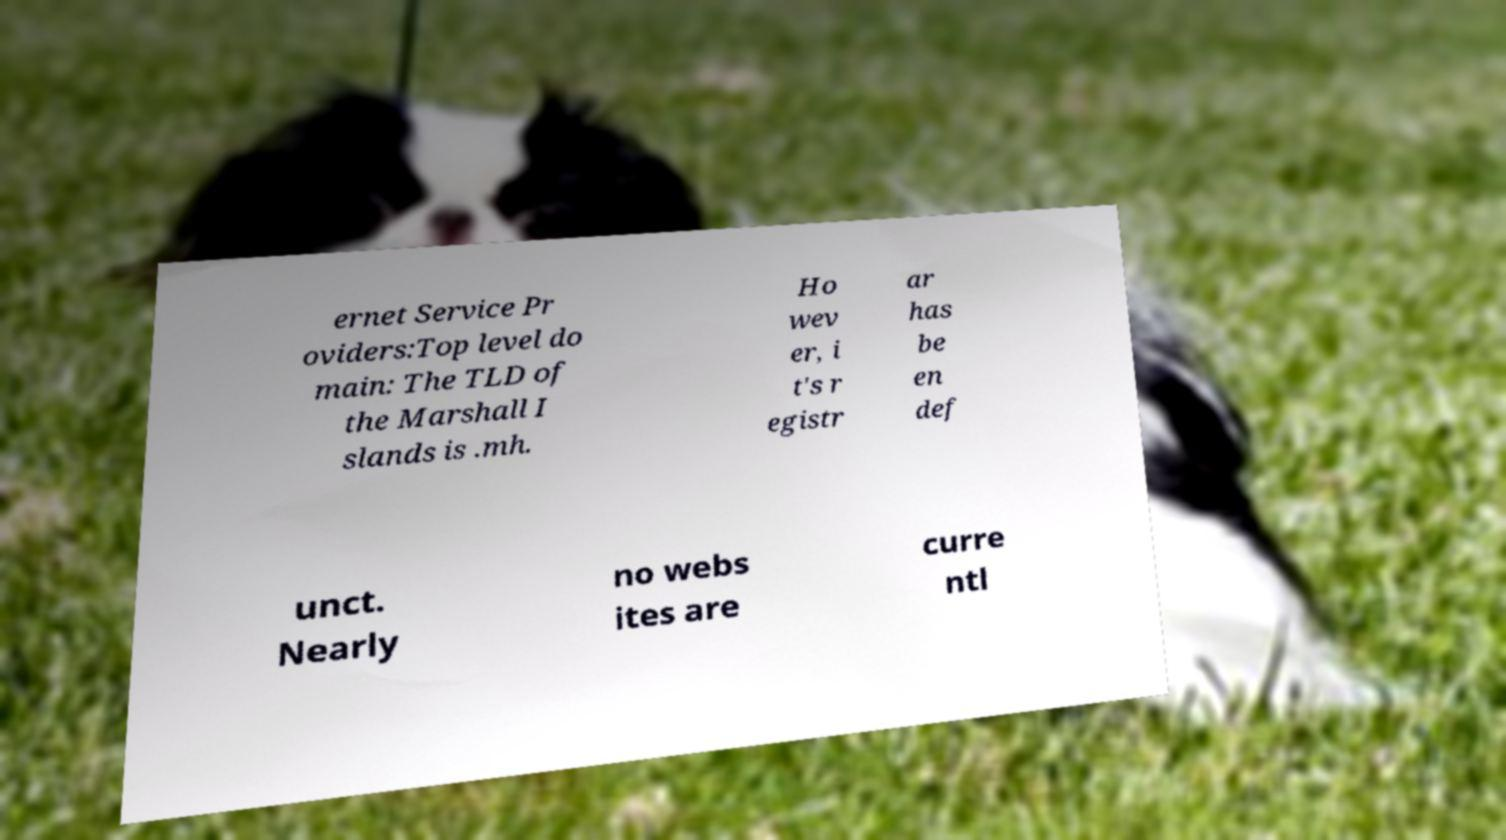Please read and relay the text visible in this image. What does it say? ernet Service Pr oviders:Top level do main: The TLD of the Marshall I slands is .mh. Ho wev er, i t's r egistr ar has be en def unct. Nearly no webs ites are curre ntl 